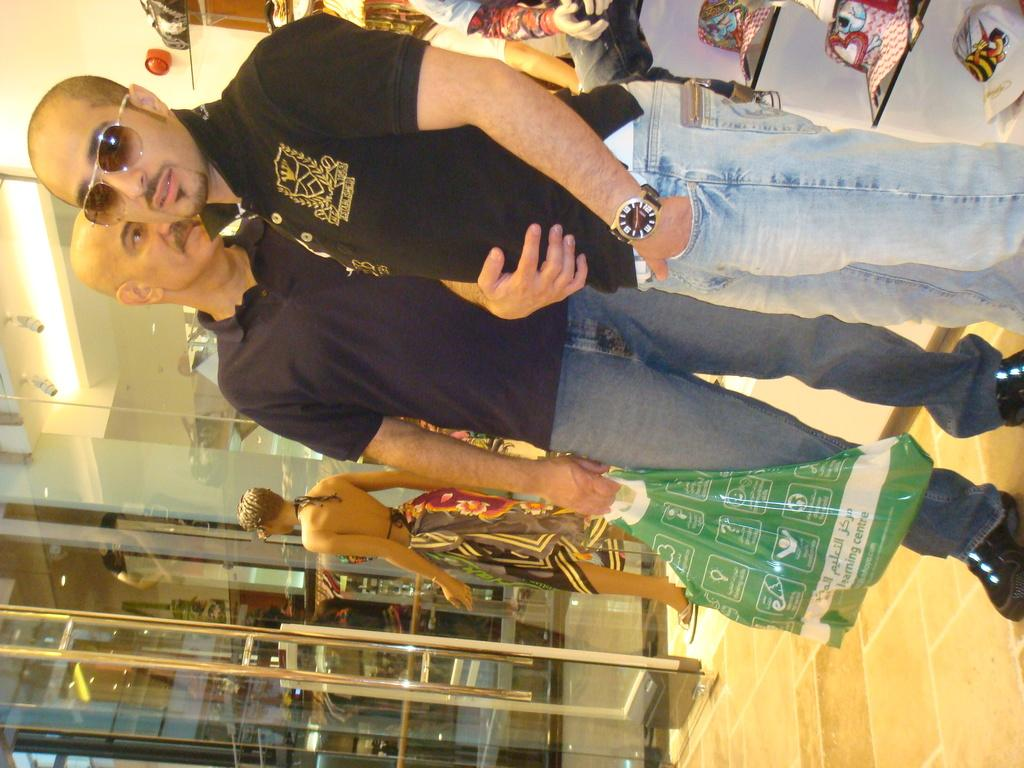How many people are in the image? There are people in the image, but the exact number is not specified. What is the man holding in the image? The man is holding a carry bag in the image. What can be seen in the background of the image? There is a glass door and hats on a shelf in the background of the image. Are there any other objects visible in the background of the image? Yes, there are other objects visible in the background of the image. What type of elbow can be seen in the image? There is no elbow visible in the image. What is the fireman doing in the image? There is no fireman present in the image. 